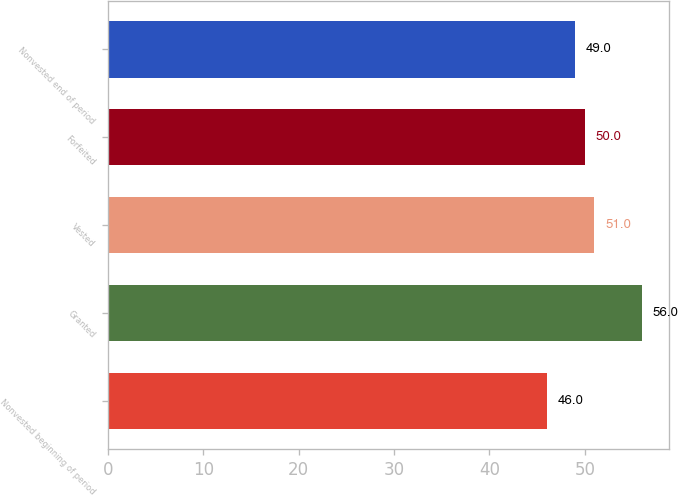<chart> <loc_0><loc_0><loc_500><loc_500><bar_chart><fcel>Nonvested beginning of period<fcel>Granted<fcel>Vested<fcel>Forfeited<fcel>Nonvested end of period<nl><fcel>46<fcel>56<fcel>51<fcel>50<fcel>49<nl></chart> 